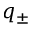<formula> <loc_0><loc_0><loc_500><loc_500>q _ { \pm }</formula> 